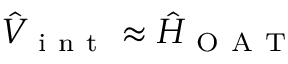<formula> <loc_0><loc_0><loc_500><loc_500>\hat { V } _ { i n t } \approx \hat { H } _ { O A T }</formula> 